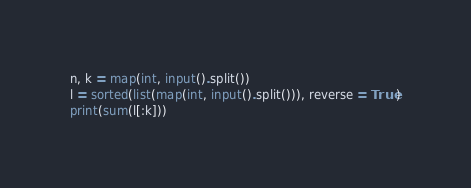Convert code to text. <code><loc_0><loc_0><loc_500><loc_500><_Python_>n, k = map(int, input().split())
l = sorted(list(map(int, input().split())), reverse = True)
print(sum(l[:k]))
</code> 